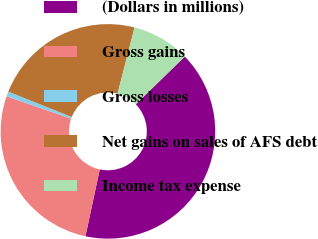<chart> <loc_0><loc_0><loc_500><loc_500><pie_chart><fcel>(Dollars in millions)<fcel>Gross gains<fcel>Gross losses<fcel>Net gains on sales of AFS debt<fcel>Income tax expense<nl><fcel>40.65%<fcel>26.95%<fcel>0.73%<fcel>22.96%<fcel>8.72%<nl></chart> 